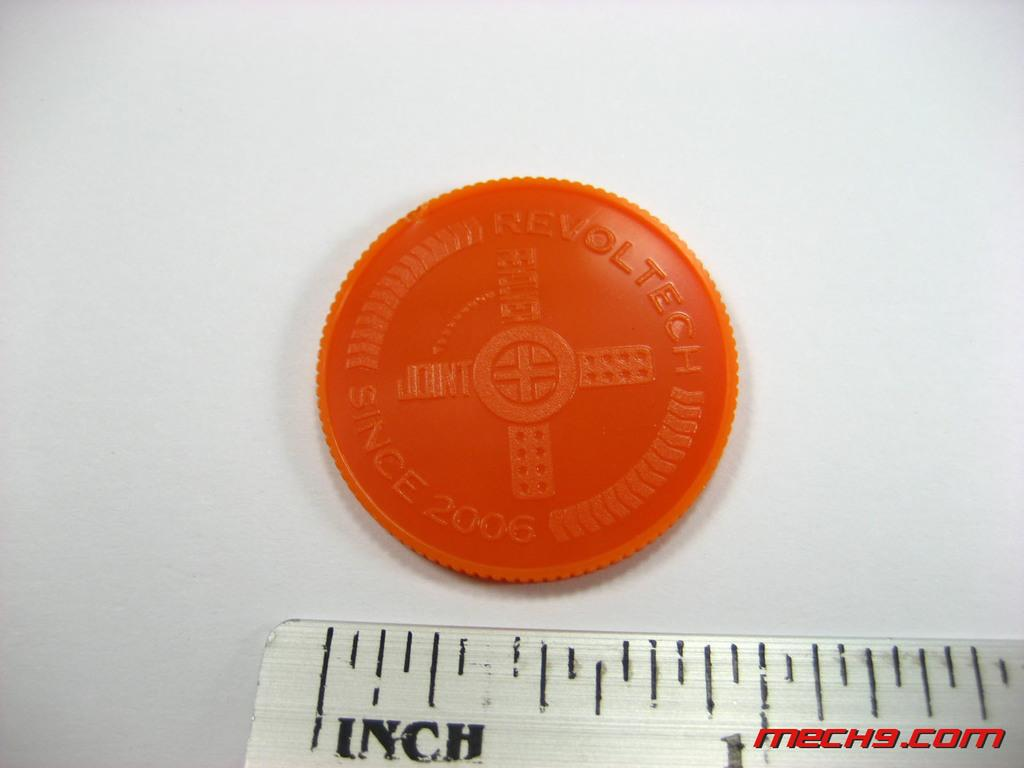<image>
Describe the image concisely. A plastic coin from revoltech is next to a ruler. 